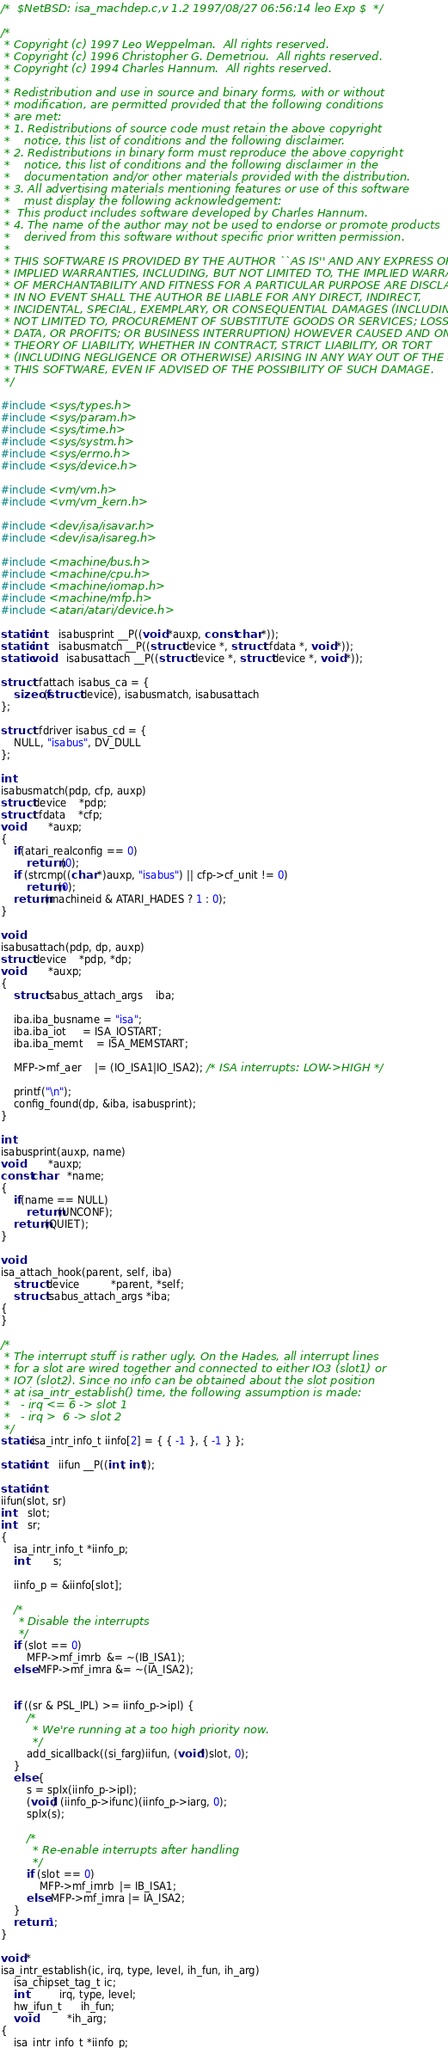<code> <loc_0><loc_0><loc_500><loc_500><_C_>/*	$NetBSD: isa_machdep.c,v 1.2 1997/08/27 06:56:14 leo Exp $	*/

/*
 * Copyright (c) 1997 Leo Weppelman.  All rights reserved.
 * Copyright (c) 1996 Christopher G. Demetriou.  All rights reserved.
 * Copyright (c) 1994 Charles Hannum.  All rights reserved.
 *
 * Redistribution and use in source and binary forms, with or without
 * modification, are permitted provided that the following conditions
 * are met:
 * 1. Redistributions of source code must retain the above copyright
 *    notice, this list of conditions and the following disclaimer.
 * 2. Redistributions in binary form must reproduce the above copyright
 *    notice, this list of conditions and the following disclaimer in the
 *    documentation and/or other materials provided with the distribution.
 * 3. All advertising materials mentioning features or use of this software
 *    must display the following acknowledgement:
 *	This product includes software developed by Charles Hannum.
 * 4. The name of the author may not be used to endorse or promote products
 *    derived from this software without specific prior written permission.
 *
 * THIS SOFTWARE IS PROVIDED BY THE AUTHOR ``AS IS'' AND ANY EXPRESS OR
 * IMPLIED WARRANTIES, INCLUDING, BUT NOT LIMITED TO, THE IMPLIED WARRANTIES
 * OF MERCHANTABILITY AND FITNESS FOR A PARTICULAR PURPOSE ARE DISCLAIMED.
 * IN NO EVENT SHALL THE AUTHOR BE LIABLE FOR ANY DIRECT, INDIRECT,
 * INCIDENTAL, SPECIAL, EXEMPLARY, OR CONSEQUENTIAL DAMAGES (INCLUDING, BUT
 * NOT LIMITED TO, PROCUREMENT OF SUBSTITUTE GOODS OR SERVICES; LOSS OF USE,
 * DATA, OR PROFITS; OR BUSINESS INTERRUPTION) HOWEVER CAUSED AND ON ANY
 * THEORY OF LIABILITY, WHETHER IN CONTRACT, STRICT LIABILITY, OR TORT
 * (INCLUDING NEGLIGENCE OR OTHERWISE) ARISING IN ANY WAY OUT OF THE USE OF
 * THIS SOFTWARE, EVEN IF ADVISED OF THE POSSIBILITY OF SUCH DAMAGE.
 */

#include <sys/types.h>
#include <sys/param.h>
#include <sys/time.h>
#include <sys/systm.h>
#include <sys/errno.h>
#include <sys/device.h>

#include <vm/vm.h>
#include <vm/vm_kern.h>

#include <dev/isa/isavar.h>
#include <dev/isa/isareg.h>

#include <machine/bus.h>
#include <machine/cpu.h>
#include <machine/iomap.h>
#include <machine/mfp.h>
#include <atari/atari/device.h>

static int	isabusprint __P((void *auxp, const char *));
static int	isabusmatch __P((struct device *, struct cfdata *, void *));
static void	isabusattach __P((struct device *, struct device *, void *));

struct cfattach isabus_ca = {
	sizeof(struct device), isabusmatch, isabusattach
};

struct cfdriver isabus_cd = {
	NULL, "isabus", DV_DULL
};

int
isabusmatch(pdp, cfp, auxp)
struct device	*pdp;
struct cfdata	*cfp;
void		*auxp;
{
	if(atari_realconfig == 0)
		return (0);
	if (strcmp((char *)auxp, "isabus") || cfp->cf_unit != 0)
		return(0);
	return(machineid & ATARI_HADES ? 1 : 0);
}

void
isabusattach(pdp, dp, auxp)
struct device	*pdp, *dp;
void		*auxp;
{
	struct isabus_attach_args	iba;

	iba.iba_busname = "isa";
	iba.iba_iot     = ISA_IOSTART;
	iba.iba_memt    = ISA_MEMSTART;

	MFP->mf_aer    |= (IO_ISA1|IO_ISA2); /* ISA interrupts: LOW->HIGH */

	printf("\n");
	config_found(dp, &iba, isabusprint);
}

int
isabusprint(auxp, name)
void		*auxp;
const char	*name;
{
	if(name == NULL)
		return(UNCONF);
	return(QUIET);
}

void
isa_attach_hook(parent, self, iba)
	struct device		  *parent, *self;
	struct isabus_attach_args *iba;
{
}

/*
 * The interrupt stuff is rather ugly. On the Hades, all interrupt lines
 * for a slot are wired together and connected to either IO3 (slot1) or
 * IO7 (slot2). Since no info can be obtained about the slot position
 * at isa_intr_establish() time, the following assumption is made:
 *   - irq <= 6 -> slot 1
 *   - irq >  6 -> slot 2
 */
static isa_intr_info_t iinfo[2] = { { -1 }, { -1 } };

static int	iifun __P((int, int));

static int
iifun(slot, sr)
int	slot;
int	sr;
{
	isa_intr_info_t *iinfo_p;
	int		s;

	iinfo_p = &iinfo[slot];

	/*
	 * Disable the interrupts
	 */
	if (slot == 0)
		MFP->mf_imrb  &= ~(IB_ISA1);
	else MFP->mf_imra &= ~(IA_ISA2);


	if ((sr & PSL_IPL) >= iinfo_p->ipl) {
		/*
		 * We're running at a too high priority now.
		 */
		add_sicallback((si_farg)iifun, (void*)slot, 0);
	}
	else {
		s = splx(iinfo_p->ipl);
		(void) (iinfo_p->ifunc)(iinfo_p->iarg, 0);
		splx(s);

		/*
		 * Re-enable interrupts after handling
		 */
		if (slot == 0)
			MFP->mf_imrb  |= IB_ISA1;
		else MFP->mf_imra |= IA_ISA2;
	}
	return 1;
}

void *
isa_intr_establish(ic, irq, type, level, ih_fun, ih_arg)
	isa_chipset_tag_t ic;
	int		  irq, type, level;
	hw_ifun_t	  ih_fun;
	void		  *ih_arg;
{
	isa_intr_info_t *iinfo_p;</code> 